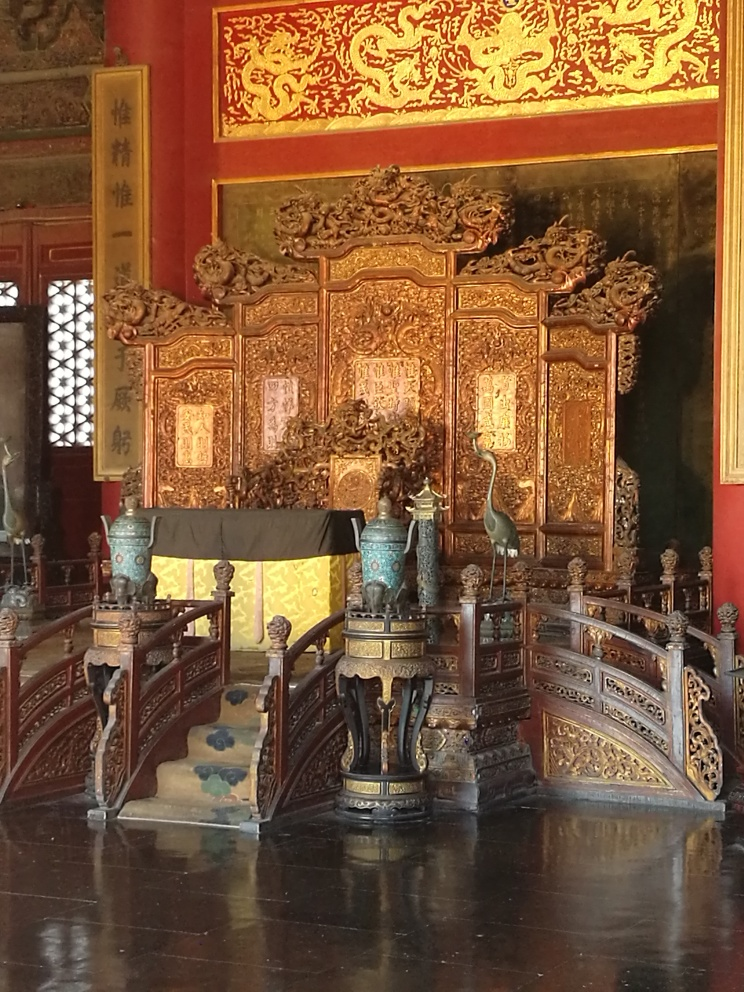How is the focus of the photo?
 Sharp 